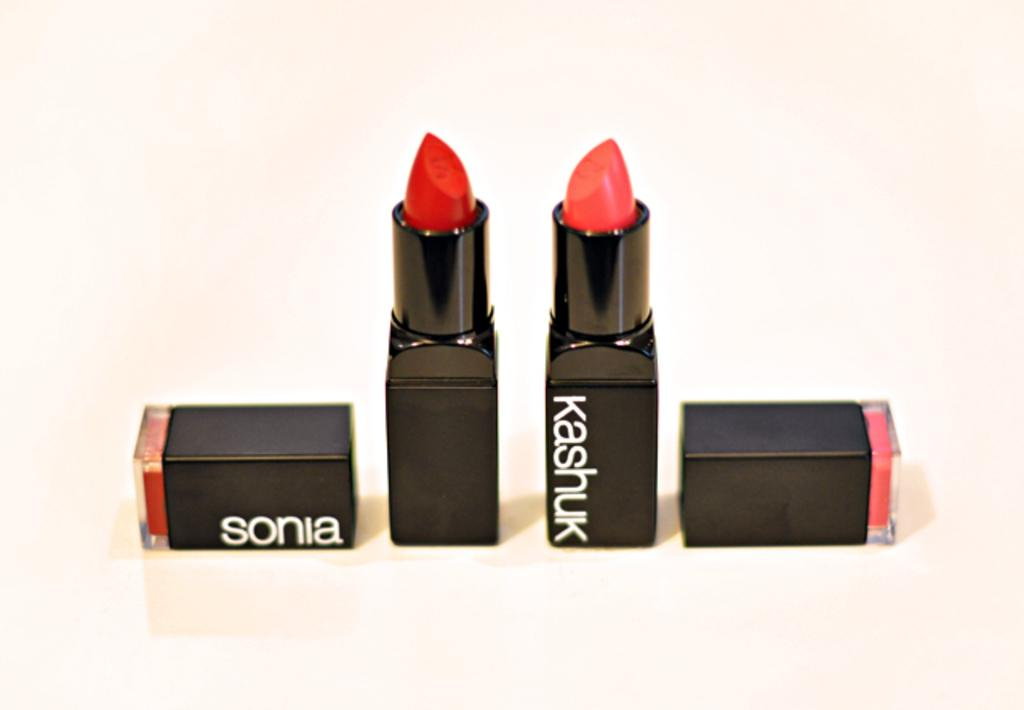What objects are present in the image? There are lipsticks in the image. How are the lipsticks arranged in the image? The lipsticks are placed on a surface. What can be seen on the surface where the lipsticks are placed? There is text written on the surface. What color is the background of the image? The background of the image is white. What type of teaching is happening in the image? There is no teaching activity depicted in the image; it features lipsticks placed on a surface with text written on it. Can you see any bears in the image? There are no bears present in the image. 